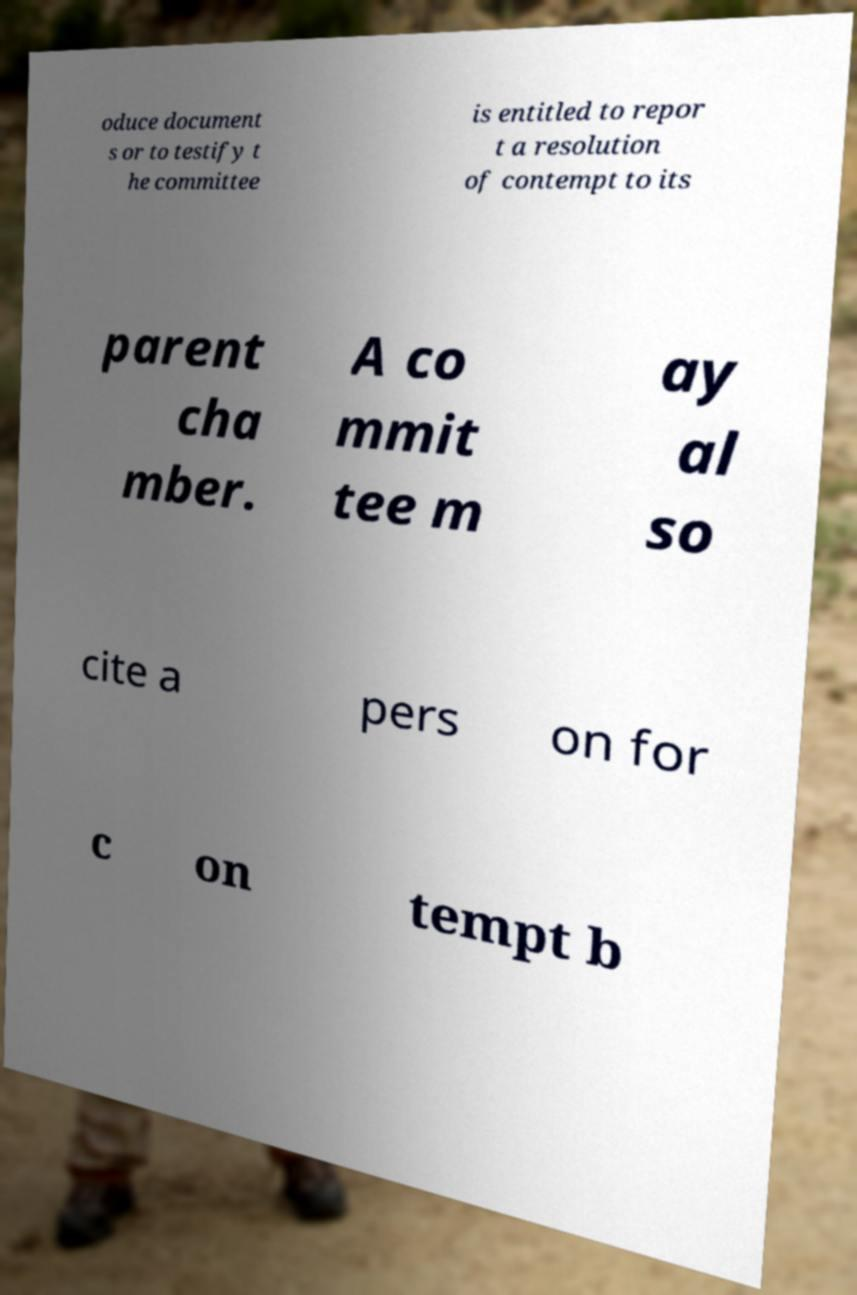Could you assist in decoding the text presented in this image and type it out clearly? oduce document s or to testify t he committee is entitled to repor t a resolution of contempt to its parent cha mber. A co mmit tee m ay al so cite a pers on for c on tempt b 